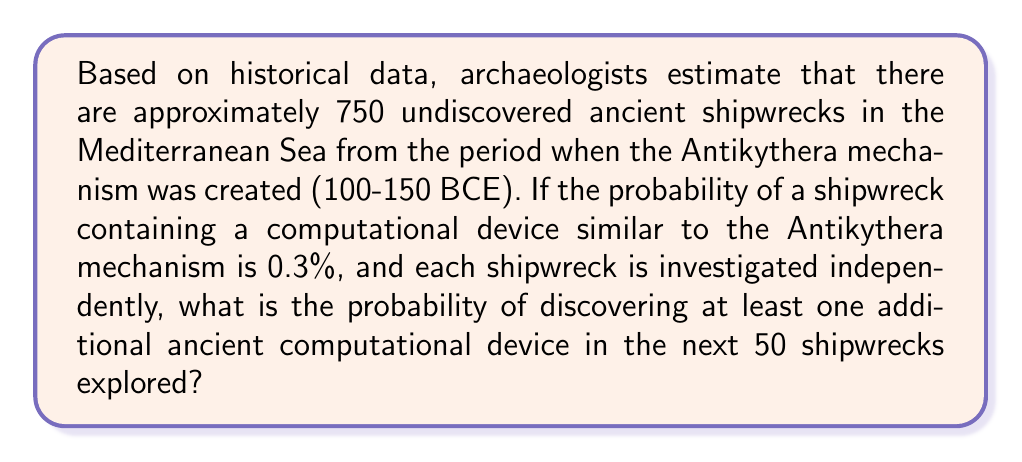Can you answer this question? Let's approach this step-by-step:

1) First, we need to calculate the probability of not finding a computational device in a single shipwreck:
   $P(\text{no device}) = 1 - 0.003 = 0.997$

2) The probability of not finding a device in all 50 shipwrecks is:
   $P(\text{no device in 50}) = (0.997)^{50}$

3) Therefore, the probability of finding at least one device is the complement of this:
   $P(\text{at least one}) = 1 - (0.997)^{50}$

4) Let's calculate this:
   $$\begin{align}
   P(\text{at least one}) &= 1 - (0.997)^{50} \\
   &= 1 - 0.8601 \\
   &= 0.1399
   \end{align}$$

5) Converting to a percentage:
   $0.1399 \times 100\% = 13.99\%$

This result aligns with our understanding as historians of the Antikythera mechanism's rarity and the challenges in deep-sea archaeology.
Answer: 13.99% 